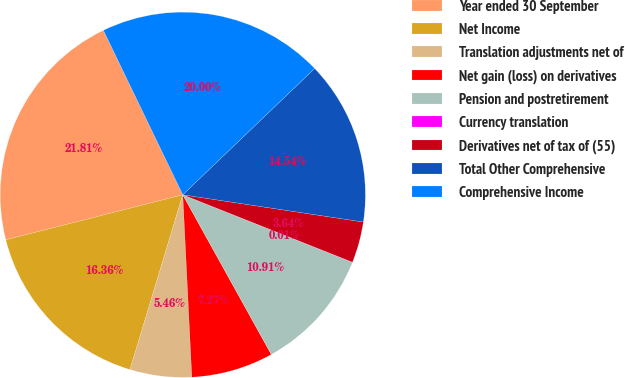<chart> <loc_0><loc_0><loc_500><loc_500><pie_chart><fcel>Year ended 30 September<fcel>Net Income<fcel>Translation adjustments net of<fcel>Net gain (loss) on derivatives<fcel>Pension and postretirement<fcel>Currency translation<fcel>Derivatives net of tax of (55)<fcel>Total Other Comprehensive<fcel>Comprehensive Income<nl><fcel>21.81%<fcel>16.36%<fcel>5.46%<fcel>7.27%<fcel>10.91%<fcel>0.01%<fcel>3.64%<fcel>14.54%<fcel>20.0%<nl></chart> 